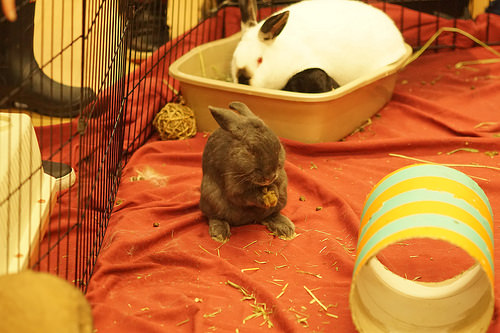<image>
Can you confirm if the rabbit is on the bed? Yes. Looking at the image, I can see the rabbit is positioned on top of the bed, with the bed providing support. 